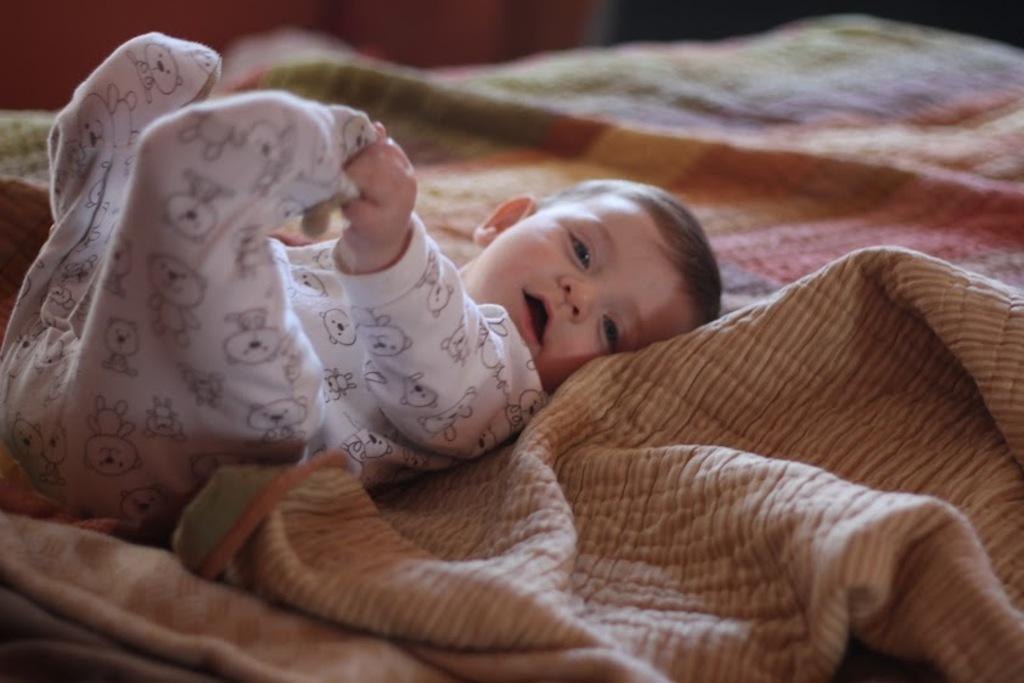What is the main subject of the picture? The main subject of the picture is a baby. What is the baby wearing in the picture? The baby is wearing a white dress in the picture. Where is the baby located in the picture? The baby is lying on a bed in the picture. How many trees can be seen in the picture? There are no trees visible in the picture; it features a baby lying on a bed while wearing a white dress. 